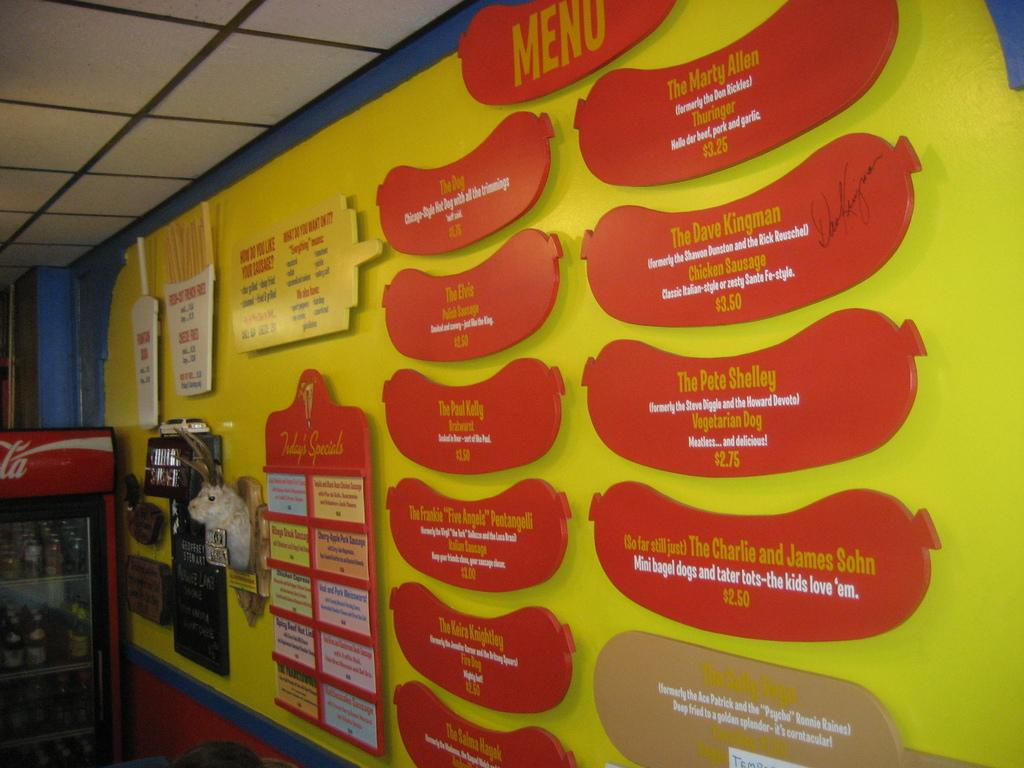Provide a one-sentence caption for the provided image. a menu of a restaurant on a yellow wall including a vegetarian dog for 2.75. 